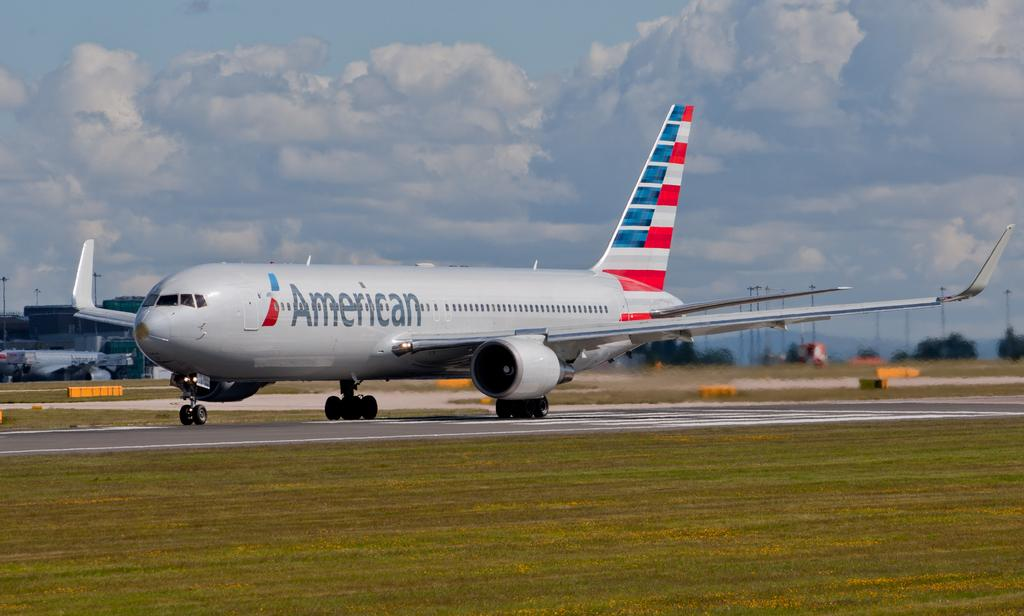<image>
Relay a brief, clear account of the picture shown. A large commercial American airlines plane is on a runway. 